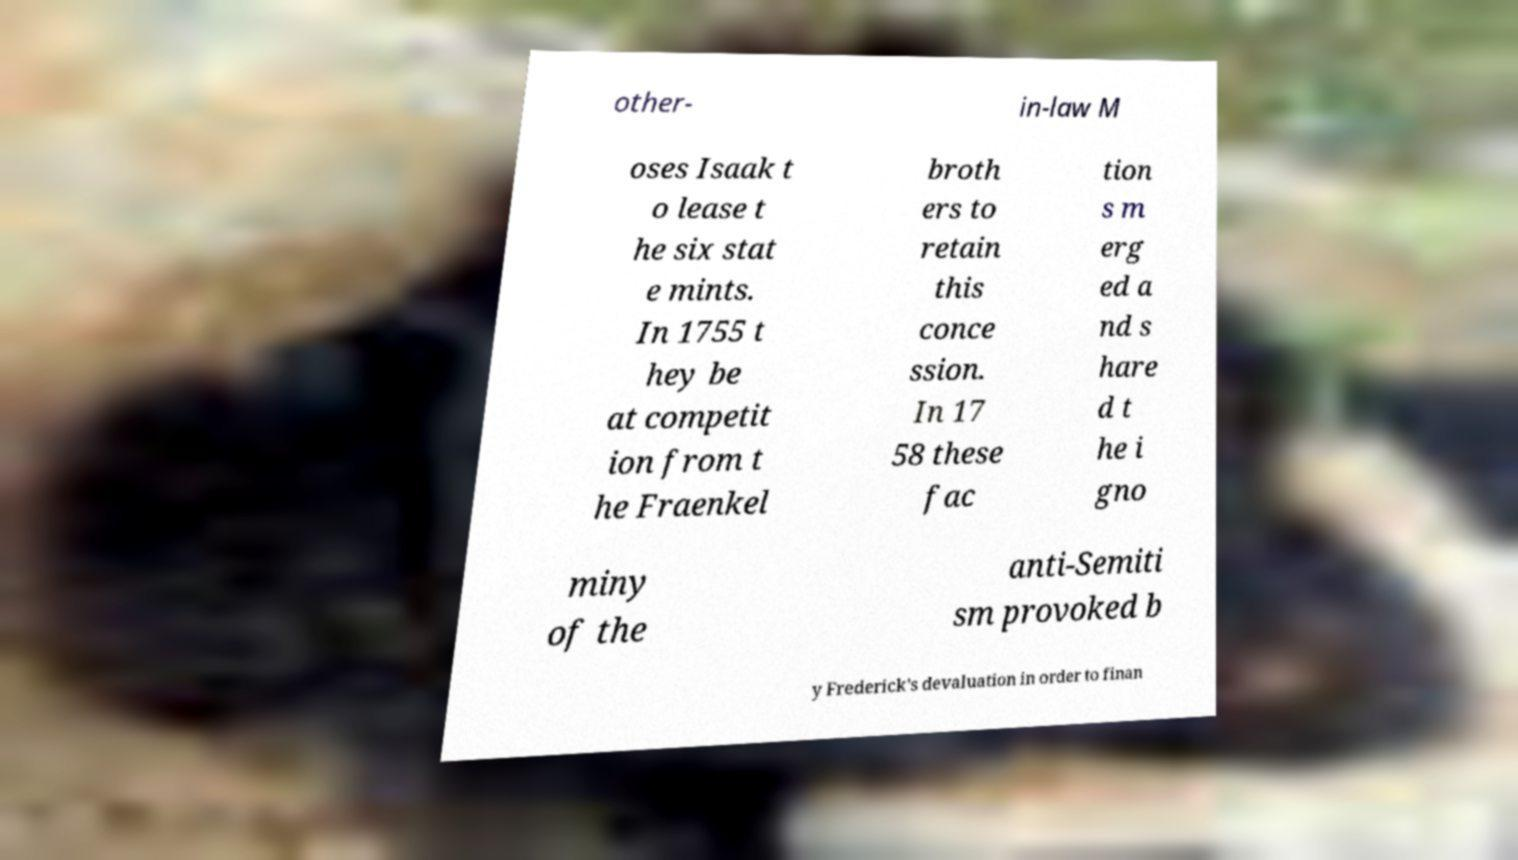Can you read and provide the text displayed in the image?This photo seems to have some interesting text. Can you extract and type it out for me? other- in-law M oses Isaak t o lease t he six stat e mints. In 1755 t hey be at competit ion from t he Fraenkel broth ers to retain this conce ssion. In 17 58 these fac tion s m erg ed a nd s hare d t he i gno miny of the anti-Semiti sm provoked b y Frederick's devaluation in order to finan 